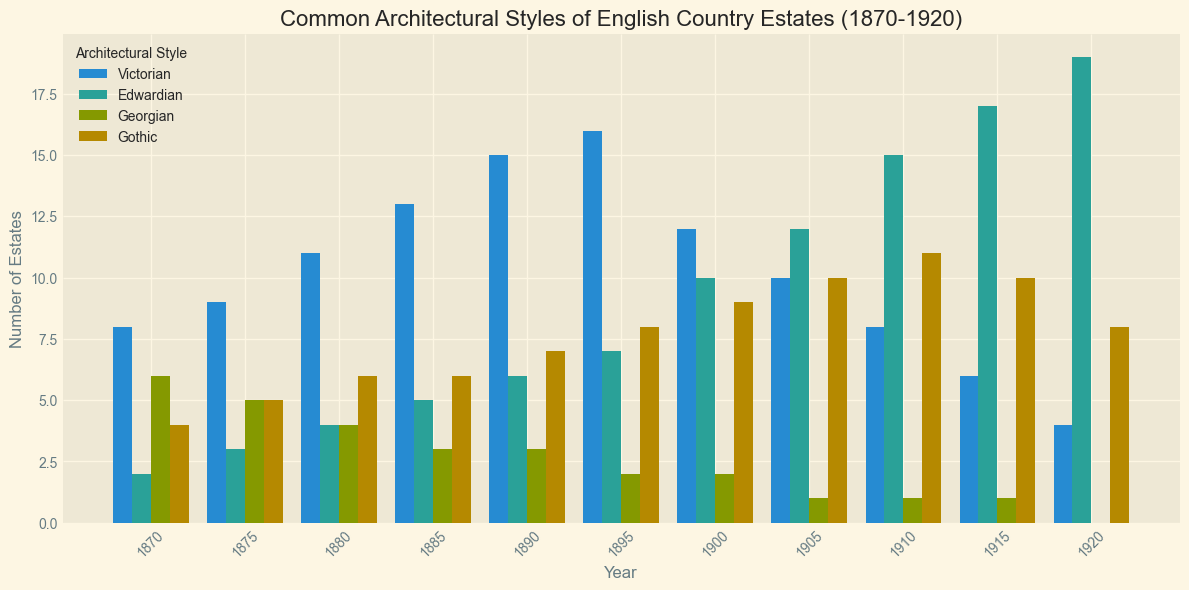What is the most common architectural style in 1870? To determine the most common architectural style in 1870, look for the bar with the greatest height in the 1870 section. The highest bar corresponds to the Victorian style.
Answer: Victorian Between 1880 and 1890, which architectural style shows the highest increase in the number of estates? Calculate the increase for each style from 1880 to 1890: Victorian (15 - 11 = 4), Edwardian (6 - 4 = 2), Georgian (3 - 4 = -1), Gothic (7 - 6 = 1). The highest increase is seen in the Victorian style.
Answer: Victorian How many estates were built in the Gothic style in total during 1870-1920? Sum the number of Gothic estates from each year: 4 + 5 + 6 + 6 + 7 + 8 + 9 + 10 + 11 + 10 + 8 = 84.
Answer: 84 Which architectural style shows a consistent increase in the number of estates from 1900 to 1920? Examine the bar heights for each style from 1900 to 1920. Only Edwardian shows a consistent increase: 10, 12, 15, 17, 19.
Answer: Edwardian What year had the highest number of Victorian estates? Locate the highest bar for the Victorian style and identify the corresponding year. The highest point is at 1895 with 16 estates.
Answer: 1895 In which year was the difference between Victorian and Edwardian estates the smallest? Compute the difference for each year and find the smallest: (1870: 8-2=6, 1875: 9-3=6, 1880: 11-4=7, 1885: 13-5=8, 1890: 15-6=9, 1895: 16-7=9, 1900: 12-10=2, 1905: 10-12=2, 1910: 8-15=7, 1915: 6-17=11, 1920: 4-19=15). The smallest difference is 2 in both 1900 and 1905.
Answer: 1900, 1905 What is the average number of Edwardian estates built each year from 1870 to 1920? Sum the Edwardian estates and divide by the number of years: (2 + 3 + 4 + 5 + 6 + 7 + 10 + 12 + 15 + 17 + 19) / 11 = 100 / 11 ≈ 9.09.
Answer: 9.09 By how much did the number of Gothic estates drop from its peak to the year 1920? Peak number of Gothic estates is 11 (1910) and in 1920 there were 8 Gothic estates. The drop is 11 - 8 = 3.
Answer: 3 